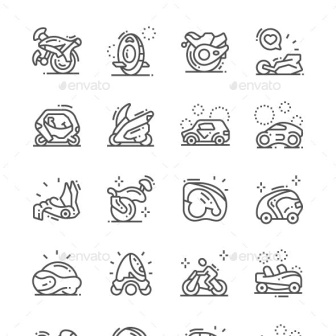Based on the icons presented, what kind of futuristic transportation system would you design for a city of tomorrow? Provide a detailed description. For a city of tomorrow, I would design an integrated and sustainable transportation system inspired by the icons presented. The system would feature a network of autonomous, eco-friendly vehicles, each serving a unique transportation need. The motorcycles would function as high-speed, agile urban pods, perfect for quick commutes within the city. The motorcycles, enhanced with mobility boosters, would provide efficient personal transport. Maglev unicycles would offer compact, eco-conscious travel through dedicated vertical tubes across the cityscape. Futuristic enclosed vehicles, operating as on-demand shuttles, would seamlessly connect residential areas with commercial hubs using AI-powered routing. These pods would be solar-powered and capable of interconnecting to form larger vehicular units during peak hours. Jet skis, revamped as hovercrafts, would run on clean energy, gliding over canals and rivers interwoven through urban areas, thus lightening road traffic. An air-borne variant would allow for scenic commutes, offering a unique traveling experience. Iterations of the racecar would function as emergency response vehicles, equipped with advanced medical and rescue technology. The entire system would be interlinked through a smart grid that manages traffic flow, energy consumption, and route optimization in real-time, ensuring a smooth and sustainable transport experience for the city's inhabitants. 